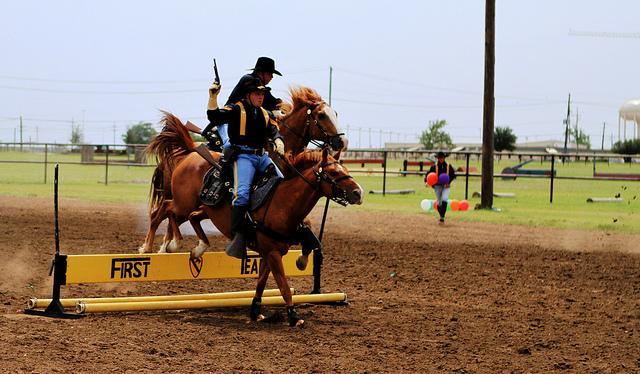Does the horse have spots?
Give a very brief answer. No. Are there large hills in the background?
Short answer required. No. Is the rider wearing boots?
Short answer required. Yes. What are the items in the background used for?
Short answer required. Jumping. What activity are the people doing?
Answer briefly. Racing. What is the color of the grass?
Quick response, please. Green. Is this a rodeo?
Write a very short answer. Yes. What are the horses jumping over?
Concise answer only. Hurdle. 